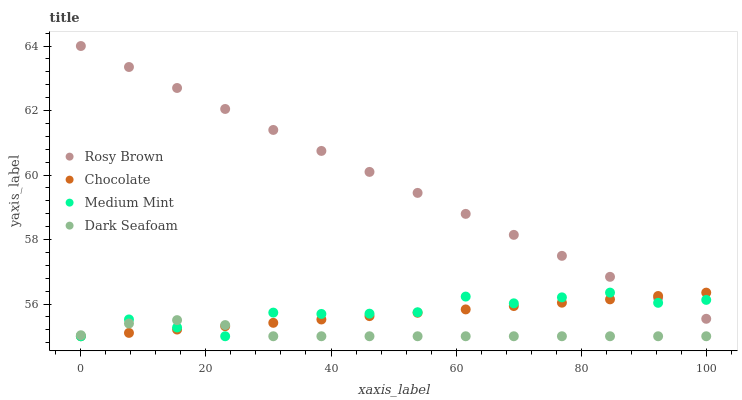Does Dark Seafoam have the minimum area under the curve?
Answer yes or no. Yes. Does Rosy Brown have the maximum area under the curve?
Answer yes or no. Yes. Does Rosy Brown have the minimum area under the curve?
Answer yes or no. No. Does Dark Seafoam have the maximum area under the curve?
Answer yes or no. No. Is Rosy Brown the smoothest?
Answer yes or no. Yes. Is Medium Mint the roughest?
Answer yes or no. Yes. Is Dark Seafoam the smoothest?
Answer yes or no. No. Is Dark Seafoam the roughest?
Answer yes or no. No. Does Medium Mint have the lowest value?
Answer yes or no. Yes. Does Rosy Brown have the lowest value?
Answer yes or no. No. Does Rosy Brown have the highest value?
Answer yes or no. Yes. Does Dark Seafoam have the highest value?
Answer yes or no. No. Is Dark Seafoam less than Rosy Brown?
Answer yes or no. Yes. Is Rosy Brown greater than Dark Seafoam?
Answer yes or no. Yes. Does Chocolate intersect Rosy Brown?
Answer yes or no. Yes. Is Chocolate less than Rosy Brown?
Answer yes or no. No. Is Chocolate greater than Rosy Brown?
Answer yes or no. No. Does Dark Seafoam intersect Rosy Brown?
Answer yes or no. No. 